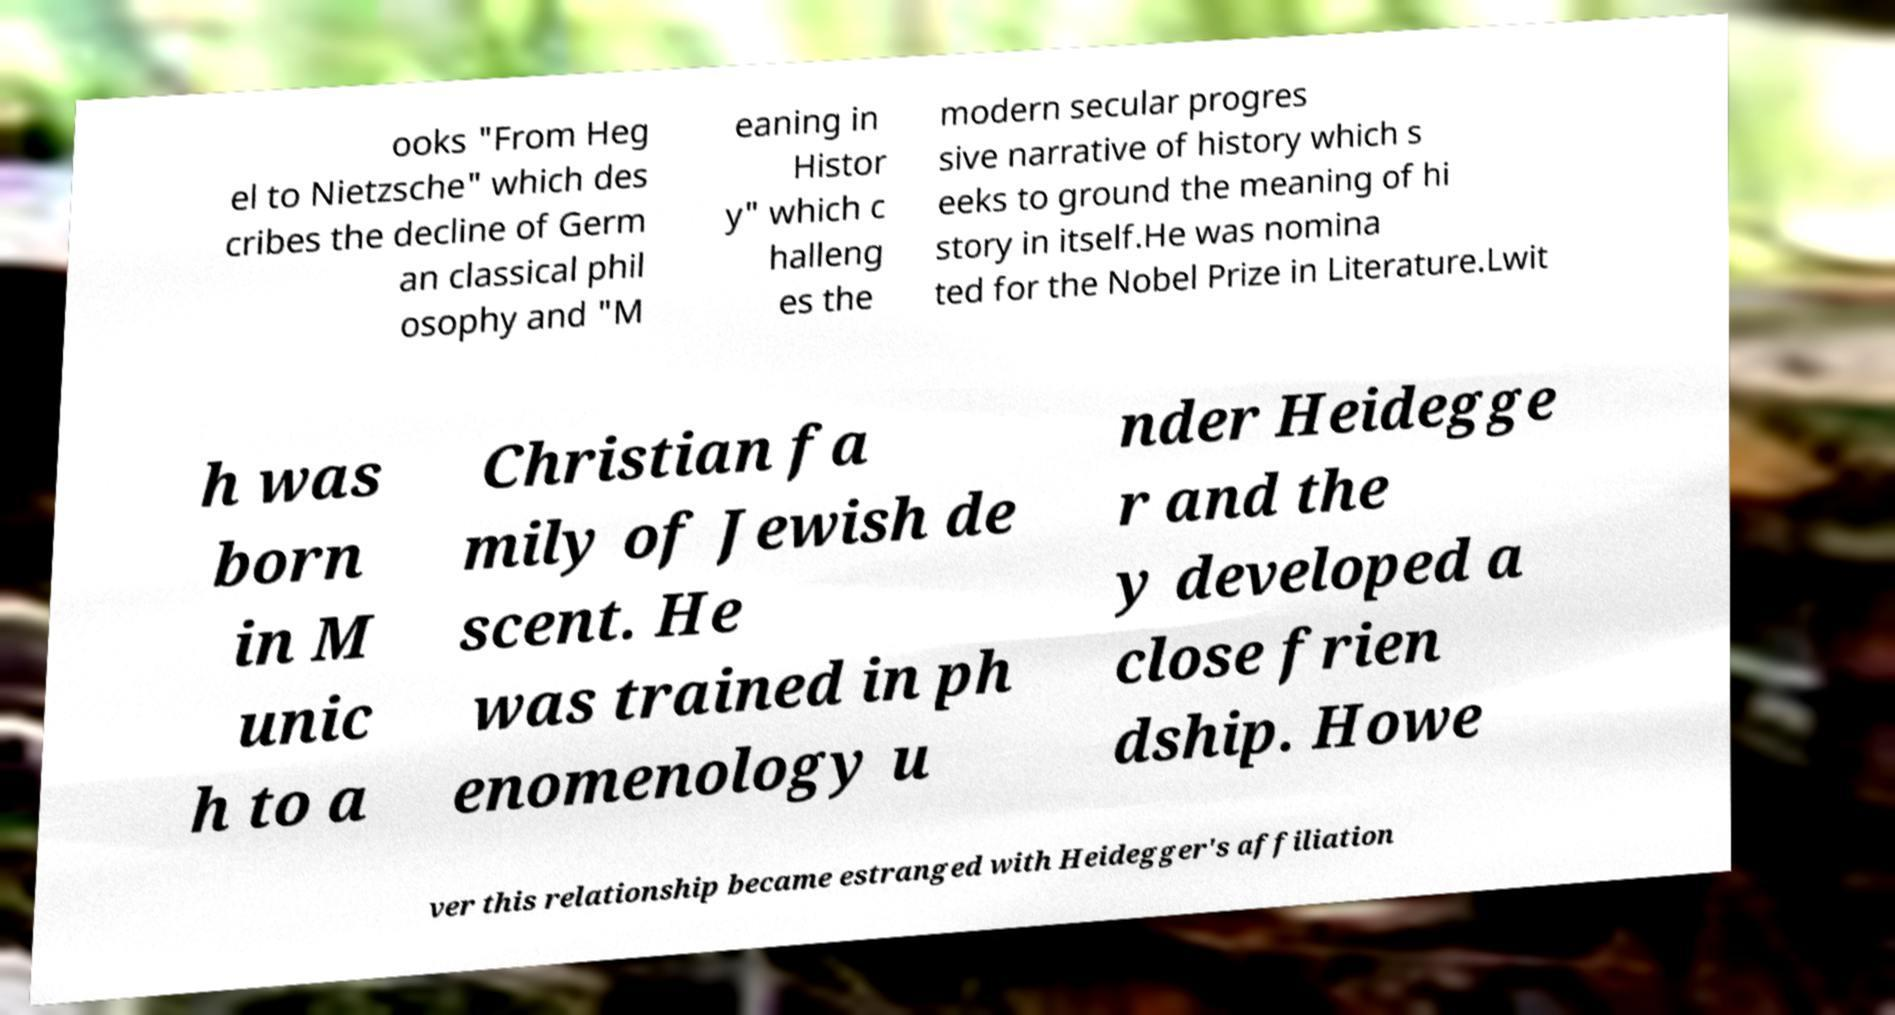There's text embedded in this image that I need extracted. Can you transcribe it verbatim? ooks "From Heg el to Nietzsche" which des cribes the decline of Germ an classical phil osophy and "M eaning in Histor y" which c halleng es the modern secular progres sive narrative of history which s eeks to ground the meaning of hi story in itself.He was nomina ted for the Nobel Prize in Literature.Lwit h was born in M unic h to a Christian fa mily of Jewish de scent. He was trained in ph enomenology u nder Heidegge r and the y developed a close frien dship. Howe ver this relationship became estranged with Heidegger's affiliation 